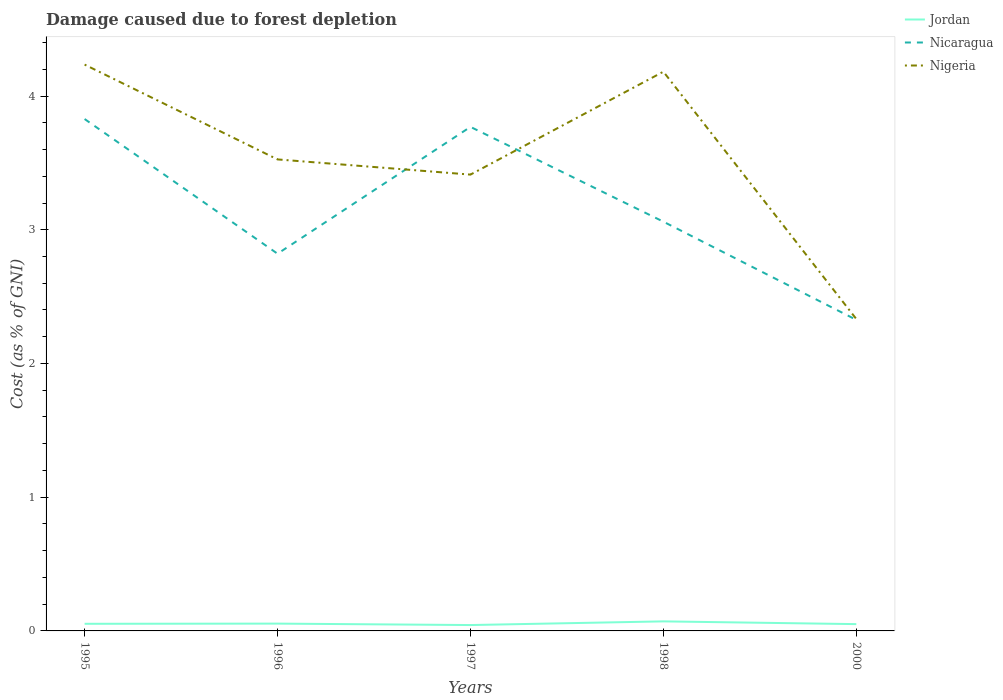How many different coloured lines are there?
Ensure brevity in your answer.  3. Does the line corresponding to Nigeria intersect with the line corresponding to Jordan?
Make the answer very short. No. Across all years, what is the maximum cost of damage caused due to forest depletion in Jordan?
Give a very brief answer. 0.04. What is the total cost of damage caused due to forest depletion in Nicaragua in the graph?
Give a very brief answer. 0.06. What is the difference between the highest and the second highest cost of damage caused due to forest depletion in Nigeria?
Offer a terse response. 1.9. Is the cost of damage caused due to forest depletion in Nicaragua strictly greater than the cost of damage caused due to forest depletion in Nigeria over the years?
Your response must be concise. No. How many lines are there?
Your response must be concise. 3. What is the difference between two consecutive major ticks on the Y-axis?
Provide a short and direct response. 1. Does the graph contain grids?
Give a very brief answer. No. How are the legend labels stacked?
Make the answer very short. Vertical. What is the title of the graph?
Your response must be concise. Damage caused due to forest depletion. Does "Canada" appear as one of the legend labels in the graph?
Provide a short and direct response. No. What is the label or title of the X-axis?
Provide a succinct answer. Years. What is the label or title of the Y-axis?
Make the answer very short. Cost (as % of GNI). What is the Cost (as % of GNI) of Jordan in 1995?
Your response must be concise. 0.05. What is the Cost (as % of GNI) in Nicaragua in 1995?
Provide a succinct answer. 3.83. What is the Cost (as % of GNI) of Nigeria in 1995?
Offer a terse response. 4.24. What is the Cost (as % of GNI) of Jordan in 1996?
Provide a short and direct response. 0.05. What is the Cost (as % of GNI) in Nicaragua in 1996?
Your answer should be very brief. 2.82. What is the Cost (as % of GNI) of Nigeria in 1996?
Provide a succinct answer. 3.53. What is the Cost (as % of GNI) in Jordan in 1997?
Make the answer very short. 0.04. What is the Cost (as % of GNI) in Nicaragua in 1997?
Keep it short and to the point. 3.77. What is the Cost (as % of GNI) in Nigeria in 1997?
Ensure brevity in your answer.  3.41. What is the Cost (as % of GNI) in Jordan in 1998?
Provide a succinct answer. 0.07. What is the Cost (as % of GNI) of Nicaragua in 1998?
Provide a short and direct response. 3.06. What is the Cost (as % of GNI) of Nigeria in 1998?
Keep it short and to the point. 4.18. What is the Cost (as % of GNI) of Jordan in 2000?
Your answer should be very brief. 0.05. What is the Cost (as % of GNI) in Nicaragua in 2000?
Offer a very short reply. 2.33. What is the Cost (as % of GNI) of Nigeria in 2000?
Provide a succinct answer. 2.33. Across all years, what is the maximum Cost (as % of GNI) of Jordan?
Offer a very short reply. 0.07. Across all years, what is the maximum Cost (as % of GNI) of Nicaragua?
Your answer should be very brief. 3.83. Across all years, what is the maximum Cost (as % of GNI) of Nigeria?
Your answer should be very brief. 4.24. Across all years, what is the minimum Cost (as % of GNI) in Jordan?
Offer a terse response. 0.04. Across all years, what is the minimum Cost (as % of GNI) in Nicaragua?
Give a very brief answer. 2.33. Across all years, what is the minimum Cost (as % of GNI) in Nigeria?
Provide a short and direct response. 2.33. What is the total Cost (as % of GNI) in Jordan in the graph?
Keep it short and to the point. 0.27. What is the total Cost (as % of GNI) in Nicaragua in the graph?
Make the answer very short. 15.8. What is the total Cost (as % of GNI) of Nigeria in the graph?
Your response must be concise. 17.69. What is the difference between the Cost (as % of GNI) of Jordan in 1995 and that in 1996?
Your response must be concise. -0. What is the difference between the Cost (as % of GNI) of Nicaragua in 1995 and that in 1996?
Offer a very short reply. 1.01. What is the difference between the Cost (as % of GNI) of Nigeria in 1995 and that in 1996?
Keep it short and to the point. 0.71. What is the difference between the Cost (as % of GNI) in Jordan in 1995 and that in 1997?
Keep it short and to the point. 0.01. What is the difference between the Cost (as % of GNI) of Nicaragua in 1995 and that in 1997?
Ensure brevity in your answer.  0.06. What is the difference between the Cost (as % of GNI) in Nigeria in 1995 and that in 1997?
Provide a succinct answer. 0.82. What is the difference between the Cost (as % of GNI) of Jordan in 1995 and that in 1998?
Keep it short and to the point. -0.02. What is the difference between the Cost (as % of GNI) in Nicaragua in 1995 and that in 1998?
Your answer should be very brief. 0.77. What is the difference between the Cost (as % of GNI) of Nigeria in 1995 and that in 1998?
Offer a very short reply. 0.05. What is the difference between the Cost (as % of GNI) in Jordan in 1995 and that in 2000?
Your response must be concise. 0. What is the difference between the Cost (as % of GNI) in Nicaragua in 1995 and that in 2000?
Your answer should be very brief. 1.5. What is the difference between the Cost (as % of GNI) of Nigeria in 1995 and that in 2000?
Make the answer very short. 1.9. What is the difference between the Cost (as % of GNI) of Jordan in 1996 and that in 1997?
Ensure brevity in your answer.  0.01. What is the difference between the Cost (as % of GNI) in Nicaragua in 1996 and that in 1997?
Ensure brevity in your answer.  -0.95. What is the difference between the Cost (as % of GNI) of Nigeria in 1996 and that in 1997?
Give a very brief answer. 0.11. What is the difference between the Cost (as % of GNI) in Jordan in 1996 and that in 1998?
Your answer should be compact. -0.02. What is the difference between the Cost (as % of GNI) in Nicaragua in 1996 and that in 1998?
Offer a very short reply. -0.24. What is the difference between the Cost (as % of GNI) of Nigeria in 1996 and that in 1998?
Ensure brevity in your answer.  -0.66. What is the difference between the Cost (as % of GNI) of Jordan in 1996 and that in 2000?
Your answer should be very brief. 0. What is the difference between the Cost (as % of GNI) of Nicaragua in 1996 and that in 2000?
Give a very brief answer. 0.49. What is the difference between the Cost (as % of GNI) of Nigeria in 1996 and that in 2000?
Give a very brief answer. 1.19. What is the difference between the Cost (as % of GNI) in Jordan in 1997 and that in 1998?
Your answer should be compact. -0.03. What is the difference between the Cost (as % of GNI) of Nicaragua in 1997 and that in 1998?
Make the answer very short. 0.71. What is the difference between the Cost (as % of GNI) of Nigeria in 1997 and that in 1998?
Your response must be concise. -0.77. What is the difference between the Cost (as % of GNI) of Jordan in 1997 and that in 2000?
Your answer should be compact. -0.01. What is the difference between the Cost (as % of GNI) of Nicaragua in 1997 and that in 2000?
Make the answer very short. 1.44. What is the difference between the Cost (as % of GNI) in Nigeria in 1997 and that in 2000?
Your response must be concise. 1.08. What is the difference between the Cost (as % of GNI) of Jordan in 1998 and that in 2000?
Provide a short and direct response. 0.02. What is the difference between the Cost (as % of GNI) of Nicaragua in 1998 and that in 2000?
Provide a short and direct response. 0.73. What is the difference between the Cost (as % of GNI) in Nigeria in 1998 and that in 2000?
Provide a short and direct response. 1.85. What is the difference between the Cost (as % of GNI) in Jordan in 1995 and the Cost (as % of GNI) in Nicaragua in 1996?
Ensure brevity in your answer.  -2.77. What is the difference between the Cost (as % of GNI) of Jordan in 1995 and the Cost (as % of GNI) of Nigeria in 1996?
Your answer should be very brief. -3.47. What is the difference between the Cost (as % of GNI) in Nicaragua in 1995 and the Cost (as % of GNI) in Nigeria in 1996?
Your answer should be very brief. 0.3. What is the difference between the Cost (as % of GNI) in Jordan in 1995 and the Cost (as % of GNI) in Nicaragua in 1997?
Provide a succinct answer. -3.72. What is the difference between the Cost (as % of GNI) of Jordan in 1995 and the Cost (as % of GNI) of Nigeria in 1997?
Your response must be concise. -3.36. What is the difference between the Cost (as % of GNI) in Nicaragua in 1995 and the Cost (as % of GNI) in Nigeria in 1997?
Offer a terse response. 0.42. What is the difference between the Cost (as % of GNI) of Jordan in 1995 and the Cost (as % of GNI) of Nicaragua in 1998?
Give a very brief answer. -3.01. What is the difference between the Cost (as % of GNI) in Jordan in 1995 and the Cost (as % of GNI) in Nigeria in 1998?
Give a very brief answer. -4.13. What is the difference between the Cost (as % of GNI) of Nicaragua in 1995 and the Cost (as % of GNI) of Nigeria in 1998?
Provide a short and direct response. -0.35. What is the difference between the Cost (as % of GNI) in Jordan in 1995 and the Cost (as % of GNI) in Nicaragua in 2000?
Offer a very short reply. -2.27. What is the difference between the Cost (as % of GNI) of Jordan in 1995 and the Cost (as % of GNI) of Nigeria in 2000?
Keep it short and to the point. -2.28. What is the difference between the Cost (as % of GNI) of Nicaragua in 1995 and the Cost (as % of GNI) of Nigeria in 2000?
Your answer should be compact. 1.5. What is the difference between the Cost (as % of GNI) of Jordan in 1996 and the Cost (as % of GNI) of Nicaragua in 1997?
Make the answer very short. -3.71. What is the difference between the Cost (as % of GNI) of Jordan in 1996 and the Cost (as % of GNI) of Nigeria in 1997?
Your response must be concise. -3.36. What is the difference between the Cost (as % of GNI) of Nicaragua in 1996 and the Cost (as % of GNI) of Nigeria in 1997?
Your answer should be very brief. -0.59. What is the difference between the Cost (as % of GNI) in Jordan in 1996 and the Cost (as % of GNI) in Nicaragua in 1998?
Your answer should be compact. -3.01. What is the difference between the Cost (as % of GNI) of Jordan in 1996 and the Cost (as % of GNI) of Nigeria in 1998?
Provide a short and direct response. -4.13. What is the difference between the Cost (as % of GNI) in Nicaragua in 1996 and the Cost (as % of GNI) in Nigeria in 1998?
Make the answer very short. -1.36. What is the difference between the Cost (as % of GNI) in Jordan in 1996 and the Cost (as % of GNI) in Nicaragua in 2000?
Keep it short and to the point. -2.27. What is the difference between the Cost (as % of GNI) of Jordan in 1996 and the Cost (as % of GNI) of Nigeria in 2000?
Your response must be concise. -2.28. What is the difference between the Cost (as % of GNI) in Nicaragua in 1996 and the Cost (as % of GNI) in Nigeria in 2000?
Give a very brief answer. 0.49. What is the difference between the Cost (as % of GNI) of Jordan in 1997 and the Cost (as % of GNI) of Nicaragua in 1998?
Make the answer very short. -3.02. What is the difference between the Cost (as % of GNI) of Jordan in 1997 and the Cost (as % of GNI) of Nigeria in 1998?
Your answer should be compact. -4.14. What is the difference between the Cost (as % of GNI) in Nicaragua in 1997 and the Cost (as % of GNI) in Nigeria in 1998?
Offer a very short reply. -0.41. What is the difference between the Cost (as % of GNI) of Jordan in 1997 and the Cost (as % of GNI) of Nicaragua in 2000?
Offer a very short reply. -2.28. What is the difference between the Cost (as % of GNI) in Jordan in 1997 and the Cost (as % of GNI) in Nigeria in 2000?
Provide a succinct answer. -2.29. What is the difference between the Cost (as % of GNI) of Nicaragua in 1997 and the Cost (as % of GNI) of Nigeria in 2000?
Your response must be concise. 1.44. What is the difference between the Cost (as % of GNI) in Jordan in 1998 and the Cost (as % of GNI) in Nicaragua in 2000?
Offer a terse response. -2.25. What is the difference between the Cost (as % of GNI) of Jordan in 1998 and the Cost (as % of GNI) of Nigeria in 2000?
Your answer should be compact. -2.26. What is the difference between the Cost (as % of GNI) of Nicaragua in 1998 and the Cost (as % of GNI) of Nigeria in 2000?
Make the answer very short. 0.73. What is the average Cost (as % of GNI) of Jordan per year?
Offer a terse response. 0.05. What is the average Cost (as % of GNI) in Nicaragua per year?
Your answer should be compact. 3.16. What is the average Cost (as % of GNI) of Nigeria per year?
Keep it short and to the point. 3.54. In the year 1995, what is the difference between the Cost (as % of GNI) of Jordan and Cost (as % of GNI) of Nicaragua?
Provide a short and direct response. -3.77. In the year 1995, what is the difference between the Cost (as % of GNI) of Jordan and Cost (as % of GNI) of Nigeria?
Ensure brevity in your answer.  -4.18. In the year 1995, what is the difference between the Cost (as % of GNI) in Nicaragua and Cost (as % of GNI) in Nigeria?
Your answer should be compact. -0.41. In the year 1996, what is the difference between the Cost (as % of GNI) in Jordan and Cost (as % of GNI) in Nicaragua?
Offer a terse response. -2.77. In the year 1996, what is the difference between the Cost (as % of GNI) of Jordan and Cost (as % of GNI) of Nigeria?
Your answer should be very brief. -3.47. In the year 1996, what is the difference between the Cost (as % of GNI) of Nicaragua and Cost (as % of GNI) of Nigeria?
Your answer should be compact. -0.71. In the year 1997, what is the difference between the Cost (as % of GNI) of Jordan and Cost (as % of GNI) of Nicaragua?
Your answer should be compact. -3.73. In the year 1997, what is the difference between the Cost (as % of GNI) in Jordan and Cost (as % of GNI) in Nigeria?
Ensure brevity in your answer.  -3.37. In the year 1997, what is the difference between the Cost (as % of GNI) in Nicaragua and Cost (as % of GNI) in Nigeria?
Offer a very short reply. 0.36. In the year 1998, what is the difference between the Cost (as % of GNI) in Jordan and Cost (as % of GNI) in Nicaragua?
Ensure brevity in your answer.  -2.99. In the year 1998, what is the difference between the Cost (as % of GNI) of Jordan and Cost (as % of GNI) of Nigeria?
Make the answer very short. -4.11. In the year 1998, what is the difference between the Cost (as % of GNI) in Nicaragua and Cost (as % of GNI) in Nigeria?
Offer a terse response. -1.12. In the year 2000, what is the difference between the Cost (as % of GNI) in Jordan and Cost (as % of GNI) in Nicaragua?
Provide a short and direct response. -2.28. In the year 2000, what is the difference between the Cost (as % of GNI) in Jordan and Cost (as % of GNI) in Nigeria?
Offer a very short reply. -2.28. In the year 2000, what is the difference between the Cost (as % of GNI) of Nicaragua and Cost (as % of GNI) of Nigeria?
Your answer should be very brief. -0.01. What is the ratio of the Cost (as % of GNI) of Jordan in 1995 to that in 1996?
Your answer should be compact. 0.97. What is the ratio of the Cost (as % of GNI) of Nicaragua in 1995 to that in 1996?
Make the answer very short. 1.36. What is the ratio of the Cost (as % of GNI) of Nigeria in 1995 to that in 1996?
Your answer should be very brief. 1.2. What is the ratio of the Cost (as % of GNI) of Jordan in 1995 to that in 1997?
Make the answer very short. 1.21. What is the ratio of the Cost (as % of GNI) of Nicaragua in 1995 to that in 1997?
Give a very brief answer. 1.02. What is the ratio of the Cost (as % of GNI) in Nigeria in 1995 to that in 1997?
Make the answer very short. 1.24. What is the ratio of the Cost (as % of GNI) in Jordan in 1995 to that in 1998?
Give a very brief answer. 0.75. What is the ratio of the Cost (as % of GNI) in Nicaragua in 1995 to that in 1998?
Provide a short and direct response. 1.25. What is the ratio of the Cost (as % of GNI) of Nigeria in 1995 to that in 1998?
Keep it short and to the point. 1.01. What is the ratio of the Cost (as % of GNI) in Jordan in 1995 to that in 2000?
Your answer should be very brief. 1.05. What is the ratio of the Cost (as % of GNI) in Nicaragua in 1995 to that in 2000?
Give a very brief answer. 1.65. What is the ratio of the Cost (as % of GNI) in Nigeria in 1995 to that in 2000?
Give a very brief answer. 1.82. What is the ratio of the Cost (as % of GNI) of Jordan in 1996 to that in 1997?
Keep it short and to the point. 1.25. What is the ratio of the Cost (as % of GNI) of Nicaragua in 1996 to that in 1997?
Make the answer very short. 0.75. What is the ratio of the Cost (as % of GNI) of Nigeria in 1996 to that in 1997?
Provide a succinct answer. 1.03. What is the ratio of the Cost (as % of GNI) in Jordan in 1996 to that in 1998?
Ensure brevity in your answer.  0.77. What is the ratio of the Cost (as % of GNI) in Nicaragua in 1996 to that in 1998?
Your response must be concise. 0.92. What is the ratio of the Cost (as % of GNI) in Nigeria in 1996 to that in 1998?
Provide a short and direct response. 0.84. What is the ratio of the Cost (as % of GNI) of Jordan in 1996 to that in 2000?
Provide a short and direct response. 1.08. What is the ratio of the Cost (as % of GNI) of Nicaragua in 1996 to that in 2000?
Your answer should be very brief. 1.21. What is the ratio of the Cost (as % of GNI) of Nigeria in 1996 to that in 2000?
Provide a succinct answer. 1.51. What is the ratio of the Cost (as % of GNI) in Jordan in 1997 to that in 1998?
Your response must be concise. 0.61. What is the ratio of the Cost (as % of GNI) of Nicaragua in 1997 to that in 1998?
Provide a succinct answer. 1.23. What is the ratio of the Cost (as % of GNI) in Nigeria in 1997 to that in 1998?
Provide a short and direct response. 0.82. What is the ratio of the Cost (as % of GNI) of Jordan in 1997 to that in 2000?
Ensure brevity in your answer.  0.86. What is the ratio of the Cost (as % of GNI) in Nicaragua in 1997 to that in 2000?
Provide a succinct answer. 1.62. What is the ratio of the Cost (as % of GNI) in Nigeria in 1997 to that in 2000?
Provide a succinct answer. 1.46. What is the ratio of the Cost (as % of GNI) of Jordan in 1998 to that in 2000?
Provide a short and direct response. 1.41. What is the ratio of the Cost (as % of GNI) of Nicaragua in 1998 to that in 2000?
Your answer should be very brief. 1.32. What is the ratio of the Cost (as % of GNI) in Nigeria in 1998 to that in 2000?
Make the answer very short. 1.79. What is the difference between the highest and the second highest Cost (as % of GNI) of Jordan?
Make the answer very short. 0.02. What is the difference between the highest and the second highest Cost (as % of GNI) in Nicaragua?
Give a very brief answer. 0.06. What is the difference between the highest and the second highest Cost (as % of GNI) in Nigeria?
Your response must be concise. 0.05. What is the difference between the highest and the lowest Cost (as % of GNI) in Jordan?
Your answer should be compact. 0.03. What is the difference between the highest and the lowest Cost (as % of GNI) of Nicaragua?
Offer a terse response. 1.5. What is the difference between the highest and the lowest Cost (as % of GNI) of Nigeria?
Ensure brevity in your answer.  1.9. 